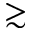<formula> <loc_0><loc_0><loc_500><loc_500>\gtrsim</formula> 